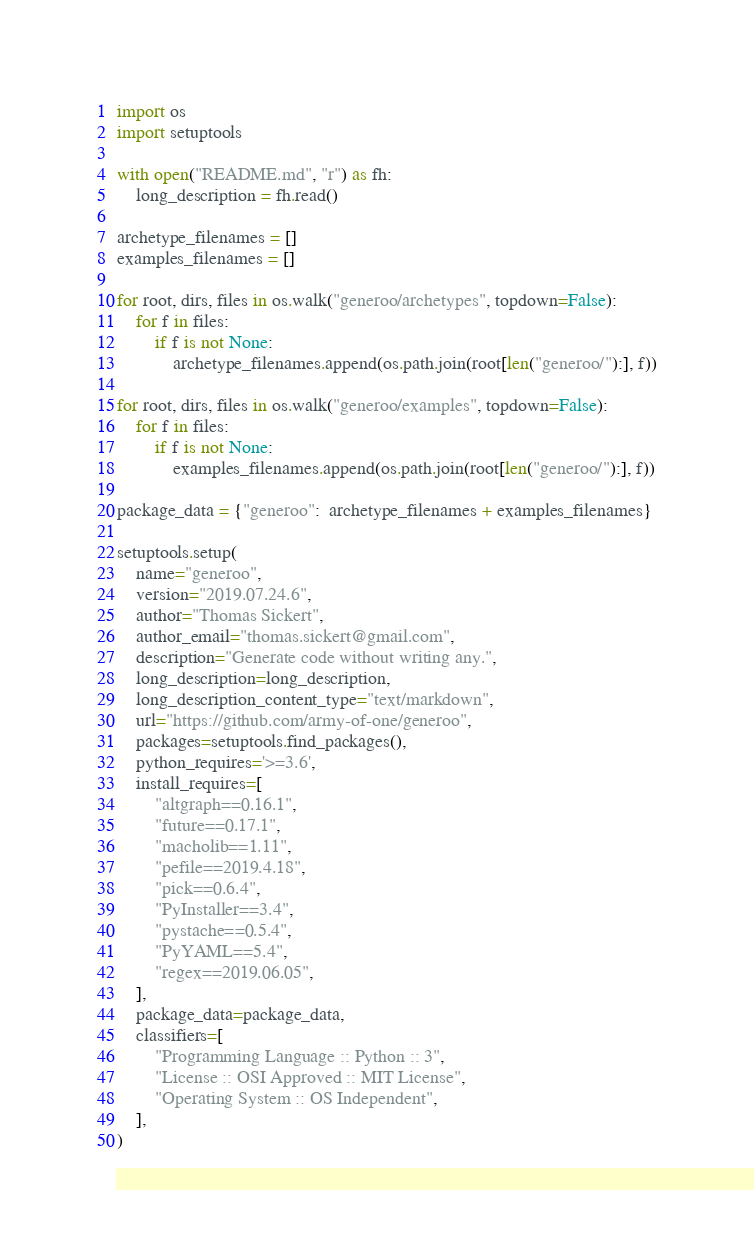Convert code to text. <code><loc_0><loc_0><loc_500><loc_500><_Python_>import os
import setuptools

with open("README.md", "r") as fh:
    long_description = fh.read()

archetype_filenames = []
examples_filenames = []

for root, dirs, files in os.walk("generoo/archetypes", topdown=False):
    for f in files:
        if f is not None:
            archetype_filenames.append(os.path.join(root[len("generoo/"):], f))

for root, dirs, files in os.walk("generoo/examples", topdown=False):
    for f in files:
        if f is not None:
            examples_filenames.append(os.path.join(root[len("generoo/"):], f))

package_data = {"generoo":  archetype_filenames + examples_filenames}

setuptools.setup(
    name="generoo",
    version="2019.07.24.6",
    author="Thomas Sickert",
    author_email="thomas.sickert@gmail.com",
    description="Generate code without writing any.",
    long_description=long_description,
    long_description_content_type="text/markdown",
    url="https://github.com/army-of-one/generoo",
    packages=setuptools.find_packages(),
    python_requires='>=3.6',
    install_requires=[
        "altgraph==0.16.1",
        "future==0.17.1",
        "macholib==1.11",
        "pefile==2019.4.18",
        "pick==0.6.4",
        "PyInstaller==3.4",
        "pystache==0.5.4",
        "PyYAML==5.4",
        "regex==2019.06.05",
    ],
    package_data=package_data,
    classifiers=[
        "Programming Language :: Python :: 3",
        "License :: OSI Approved :: MIT License",
        "Operating System :: OS Independent",
    ],
)
</code> 